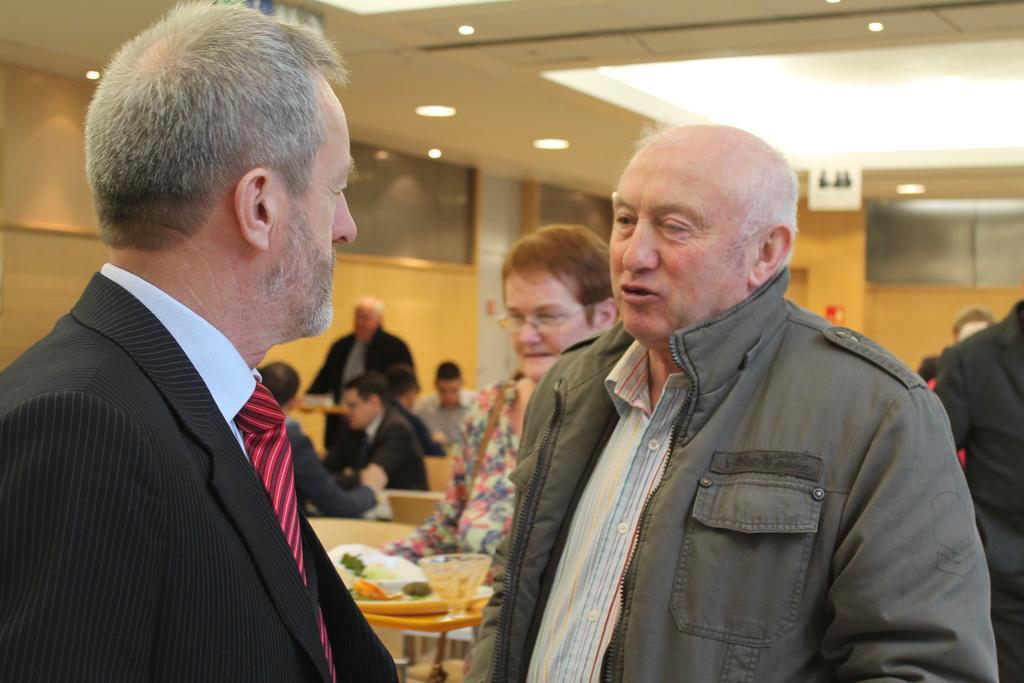How would you summarize this image in a sentence or two? In this image I can see a person wearing shirt, tie and black colored blazer and another person wearing grey colored jacket are standing. I can see another person holding a tray with few plates and a glass in it. In the background I can see few benches, few persons sitting on them, few persons standing, the cream colored wall, the ceiling and few lights to the ceiling. 